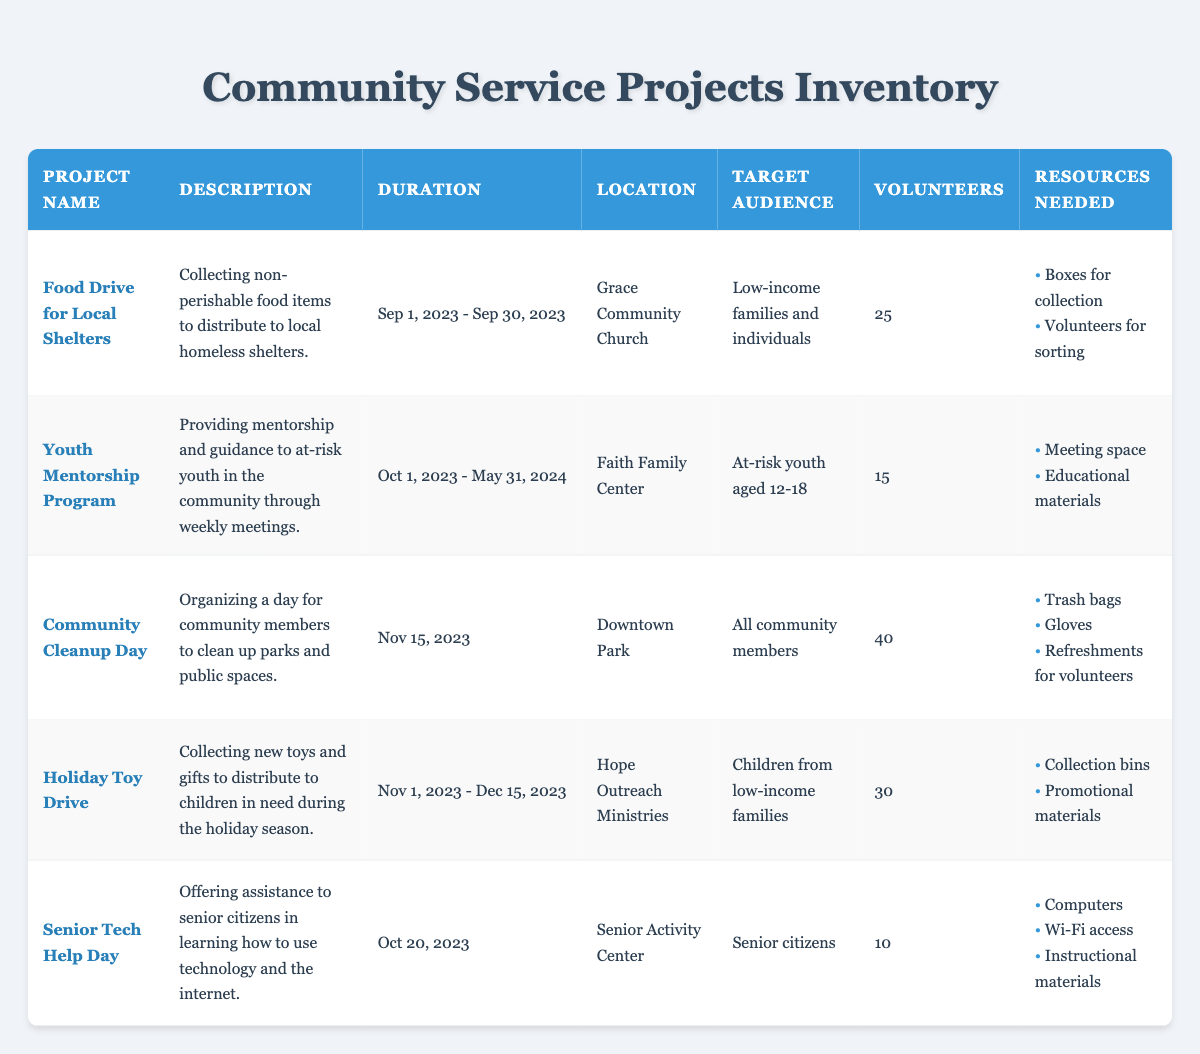What is the target audience for the "Holiday Toy Drive"? From the table, we can directly look at the row for the "Holiday Toy Drive" project, which states that the target audience is "Children from low-income families."
Answer: Children from low-income families How many volunteers are needed for the "Community Cleanup Day"? By referring to the row for the "Community Cleanup Day," we can find that the Volunteer Count is listed as 40.
Answer: 40 What resources are needed for the "Senior Tech Help Day"? In the table, under the row for "Senior Tech Help Day," it lists the resources needed as: "Computers," "Wi-Fi access," and "Instructional materials."
Answer: Computers, Wi-Fi access, Instructional materials Which project has the longest duration based on its start and end dates? To determine the longest duration, we examine each project's date range. The "Youth Mentorship Program" runs from October 1, 2023, to May 31, 2024, which is 8 months, while others vary between 1 day to 2.5 months. Therefore, this project has the longest duration.
Answer: Youth Mentorship Program Is the "Food Drive for Local Shelters" the project with the highest number of volunteers? Comparing the Volunteer Counts: Food Drive (25), Youth Mentorship Program (15), Community Cleanup Day (40), Holiday Toy Drive (30), and Senior Tech Help Day (10). The highest count belongs to the Community Cleanup Day with 40 volunteers, meaning the answer is no.
Answer: No 